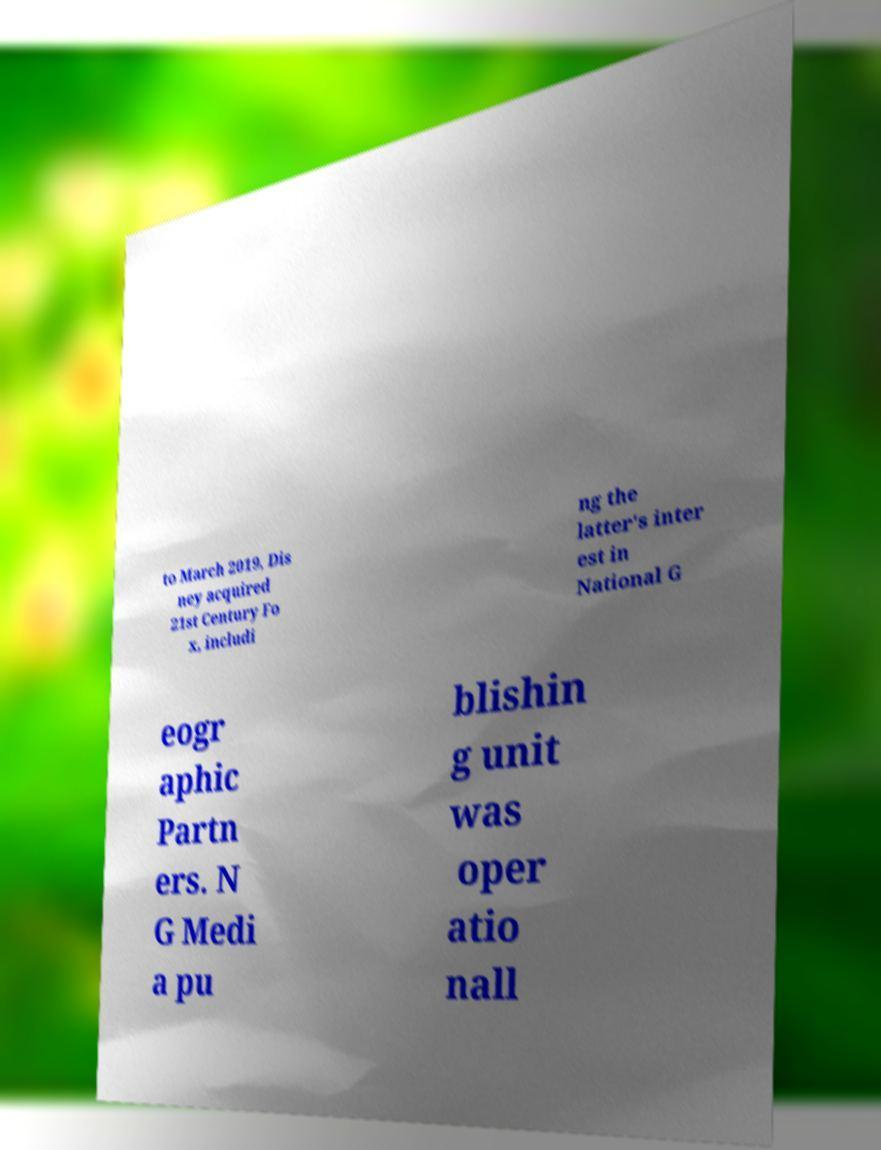Can you accurately transcribe the text from the provided image for me? to March 2019, Dis ney acquired 21st Century Fo x, includi ng the latter's inter est in National G eogr aphic Partn ers. N G Medi a pu blishin g unit was oper atio nall 